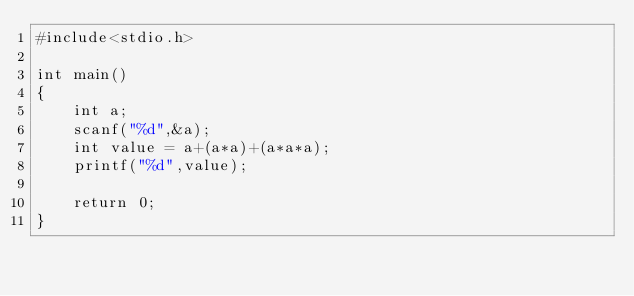Convert code to text. <code><loc_0><loc_0><loc_500><loc_500><_C_>#include<stdio.h>

int main()
{
    int a;
    scanf("%d",&a);
    int value = a+(a*a)+(a*a*a);
    printf("%d",value);
    
    return 0;
}</code> 